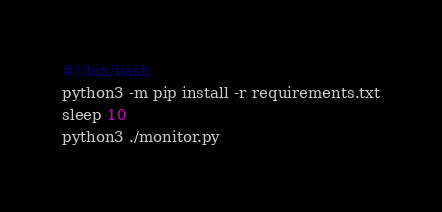Convert code to text. <code><loc_0><loc_0><loc_500><loc_500><_Bash_>#!/bin/bash
python3 -m pip install -r requirements.txt
sleep 10
python3 ./monitor.py
</code> 